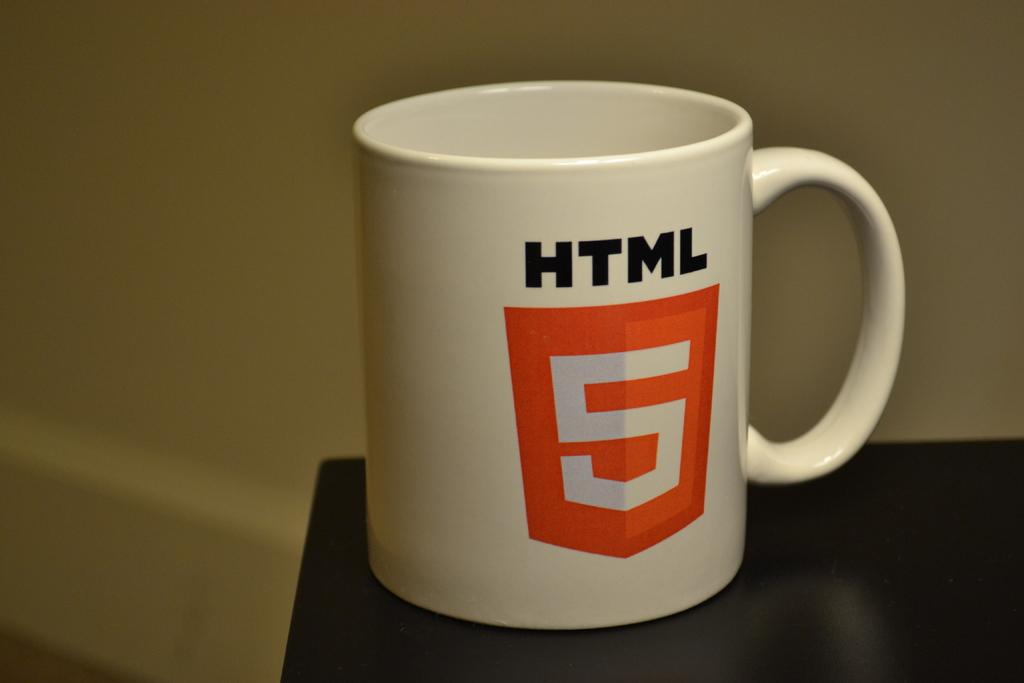<image>
Create a compact narrative representing the image presented. An HTML 5 mug sits on the ledge of a table. 